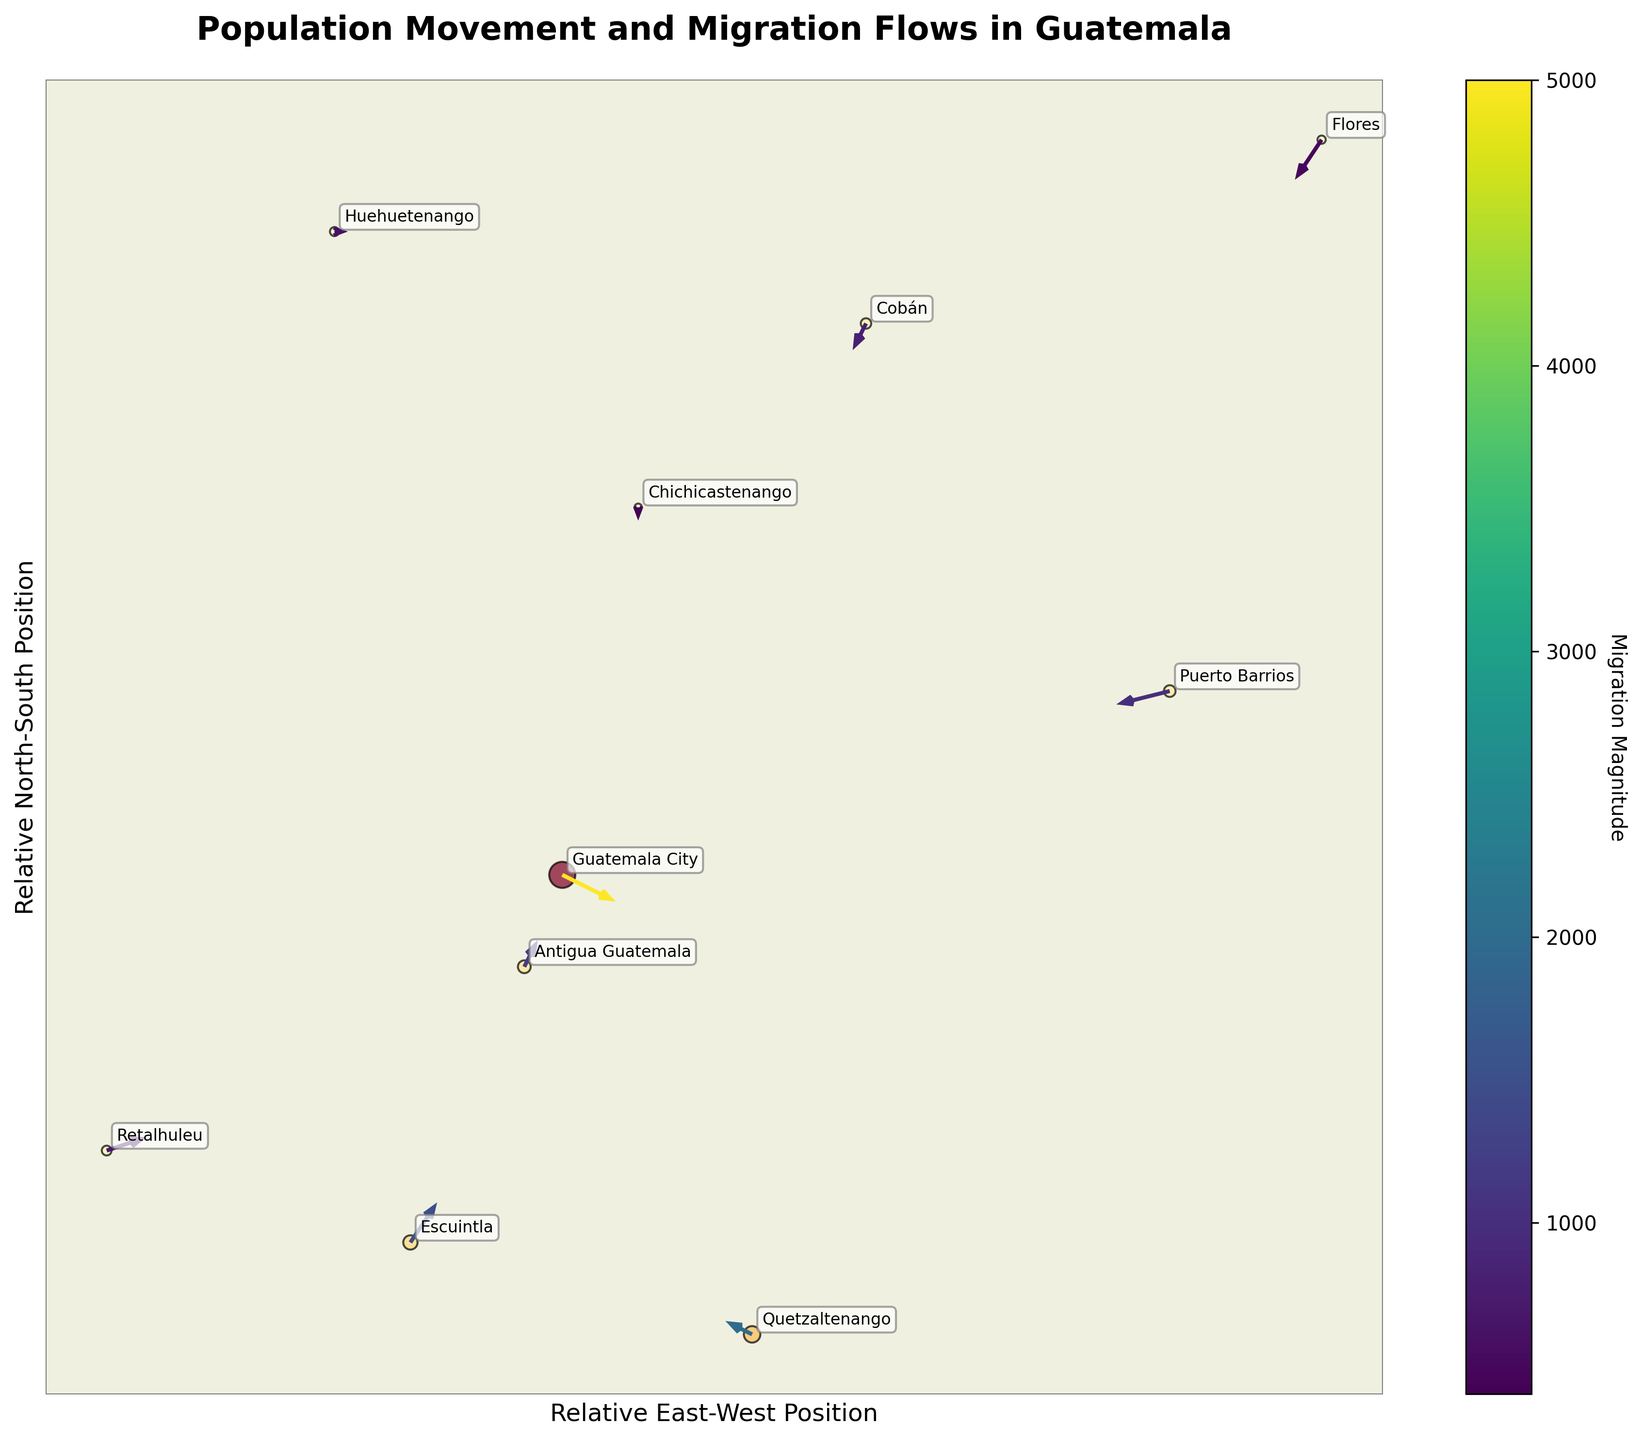Which city has the highest population migration magnitude represented on the plot? Examining the scatter points, the size of the point for Guatemala City is the largest, indicating it has the highest magnitude of migration.
Answer: Guatemala City What is the direction of the population movement from Quetzaltenango relative to X and Y axes? Observing the Quetzaltenango vector, it moves left (-1 in U) and slightly up (0.5 in V).
Answer: Left and slightly upward Which city shows the smallest migration flow on the plot? The smallest vector is for Chichicastenango, with coordinates (10, 40) and movement vector (0, -0.5).
Answer: Chichicastenango How does the direction of migration from Guatemala City compare to that from Retalhuleu? Guatemala City's population moves rightward and slightly down (2, -1), while from Retalhuleu, it moves rightward and slightly up (1.5, 0.5).
Answer: Different directions What are the East-West and North-South relative positions for Huehuetenango? Huehuetenango is situated at approximately (-30, 70), from the coordinates of the scatter point.
Answer: -30, 70 Which city has the most directed migration towards the west? Puerto Barrios has the most negative U component (-2), indicating the most westward movement.
Answer: Puerto Barrios How does the migration flow from Escuintla compare to that from Cobán in terms of direction and magnitude? Escuintla’s movement is rightward and slightly upward (1, 1.5) with a magnitude of 1500, while Cobán’s movement is leftward and downward (-0.5, -1) with a magnitude of 800.
Answer: Opposite directions; larger magnitude for Escuintla Among Flores and Antigua Guatemala, which city has a stronger migration magnitude? Flores has a magnitude of 500, whereas Antigua Guatemala has a magnitude of 1200. Therefore, Antigua Guatemala has a stronger migration magnitude.
Answer: Antigua Guatemala 